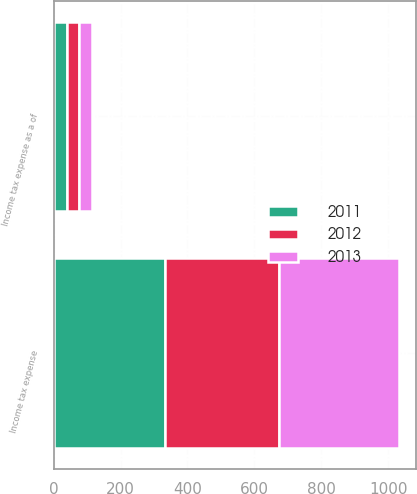Convert chart to OTSL. <chart><loc_0><loc_0><loc_500><loc_500><stacked_bar_chart><ecel><fcel>Income tax expense<fcel>Income tax expense as a of<nl><fcel>2012<fcel>340.2<fcel>37.2<nl><fcel>2013<fcel>359.4<fcel>38.1<nl><fcel>2011<fcel>333<fcel>38.4<nl></chart> 